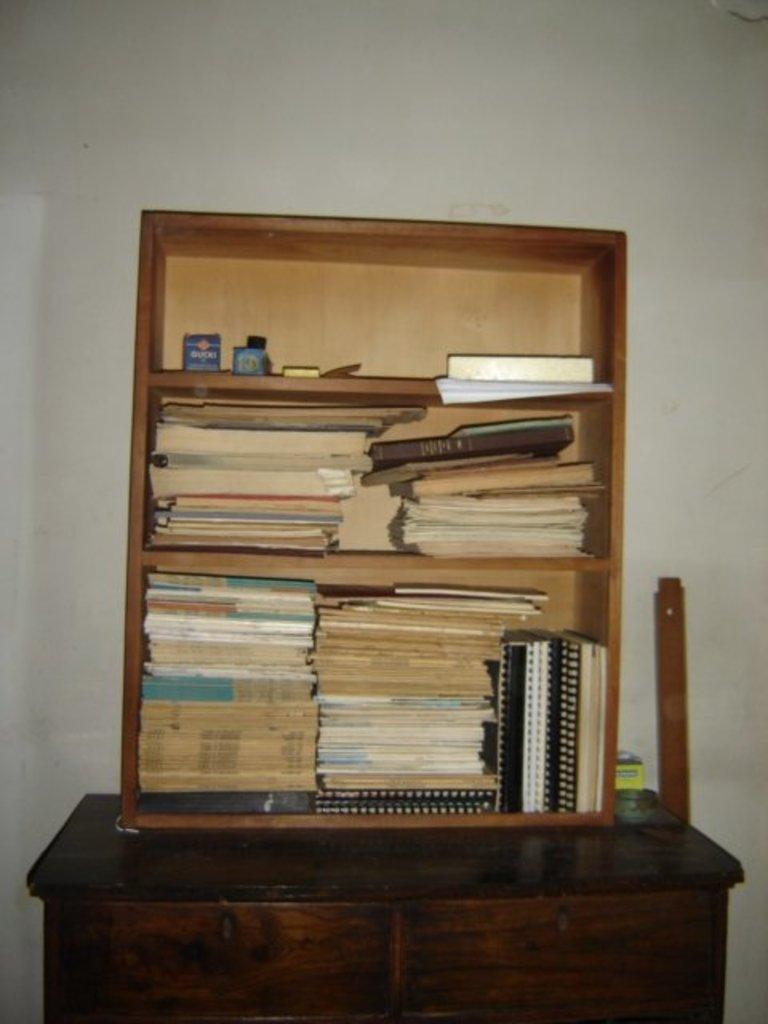What is the main object in the image? There is a rack in the image. What is placed on the rack? There are books on the rack. What is located at the bottom of the image? There is a table at the bottom of the image. What can be seen in the background of the image? There is a wall in the background of the image. How does the clam request to be balanced on the table in the image? There is no clam present in the image, and therefore no such request can be observed. 